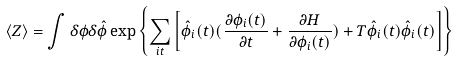Convert formula to latex. <formula><loc_0><loc_0><loc_500><loc_500>\langle Z \rangle = \int \delta \phi \delta \hat { \phi } \exp \left \{ \sum _ { i t } \left [ \hat { \phi } _ { i } ( t ) ( \frac { \partial \phi _ { i } ( t ) } { \partial t } + \frac { \partial H } { \partial \phi _ { i } ( t ) } ) + T \hat { \phi } _ { i } ( t ) \hat { \phi } _ { i } ( t ) \right ] \right \}</formula> 